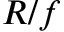<formula> <loc_0><loc_0><loc_500><loc_500>R / f</formula> 